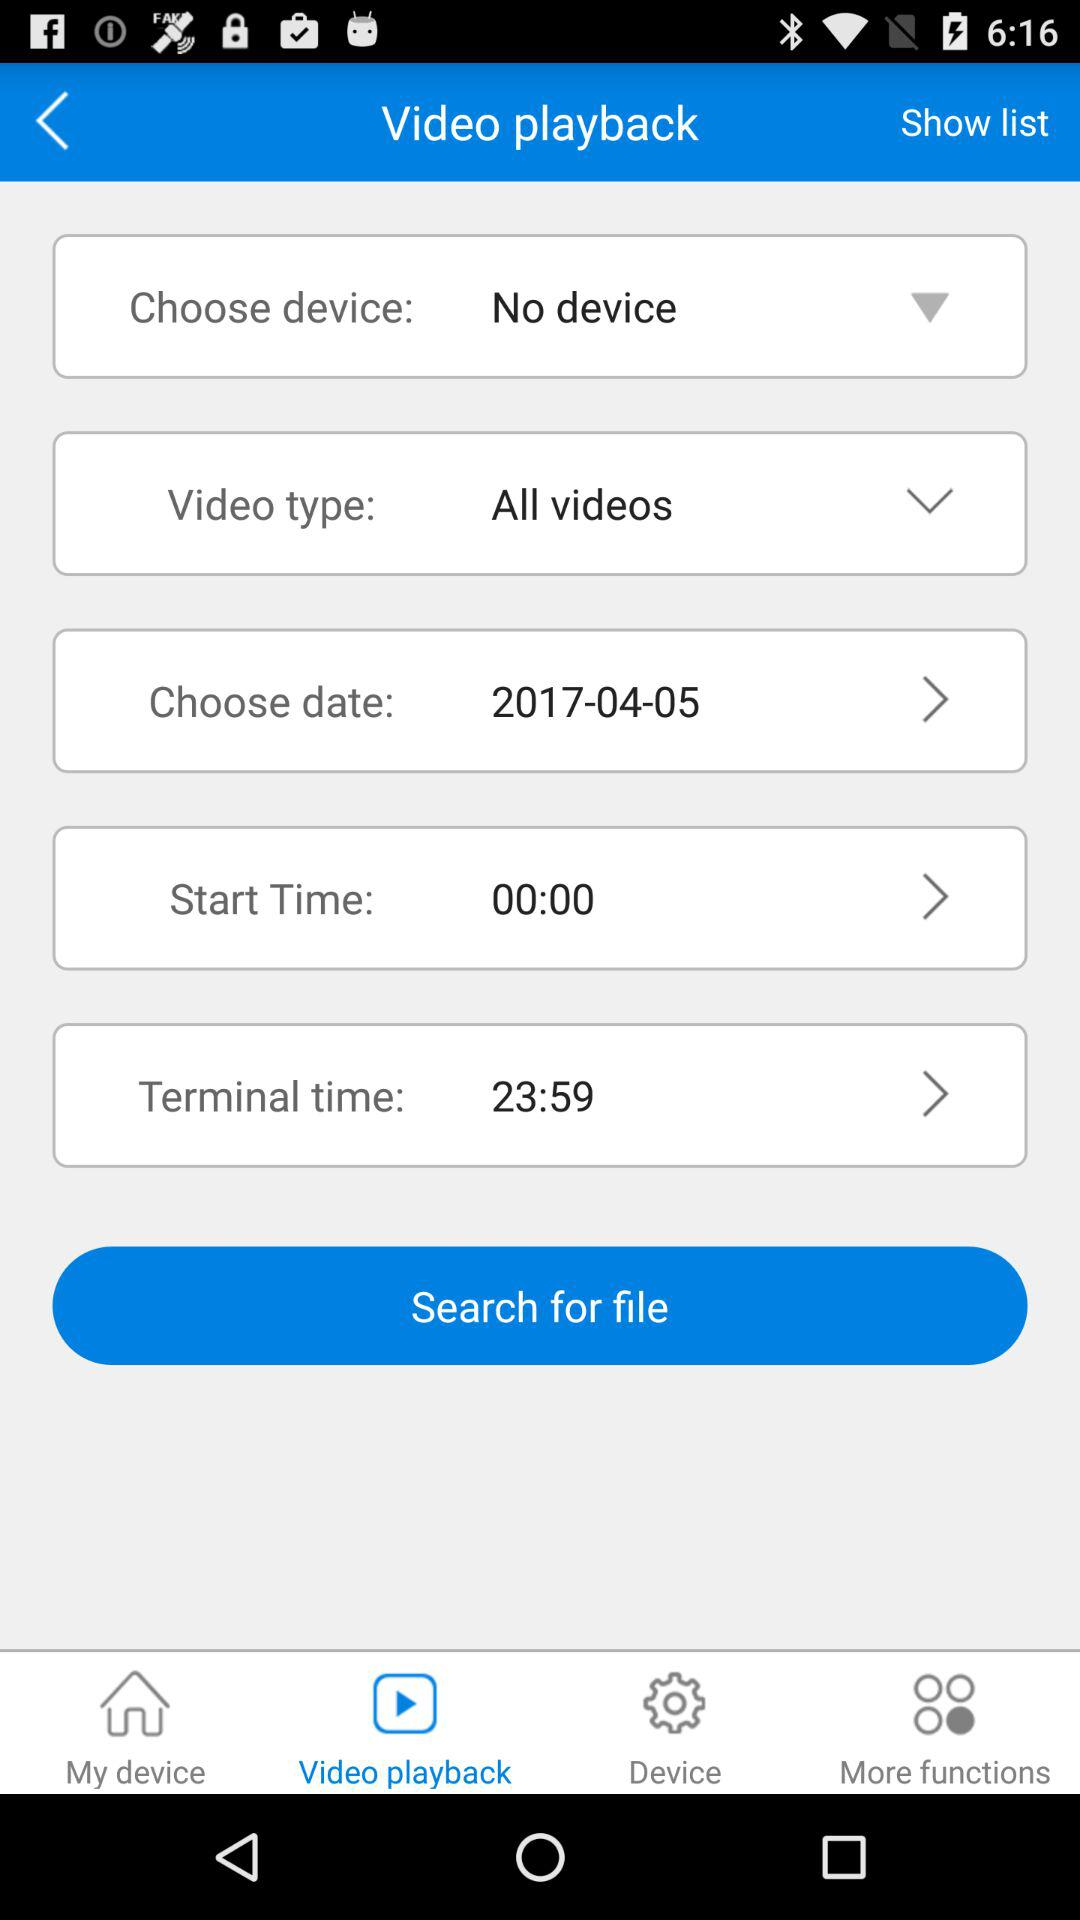How many notifications are there in "Device"?
When the provided information is insufficient, respond with <no answer>. <no answer> 